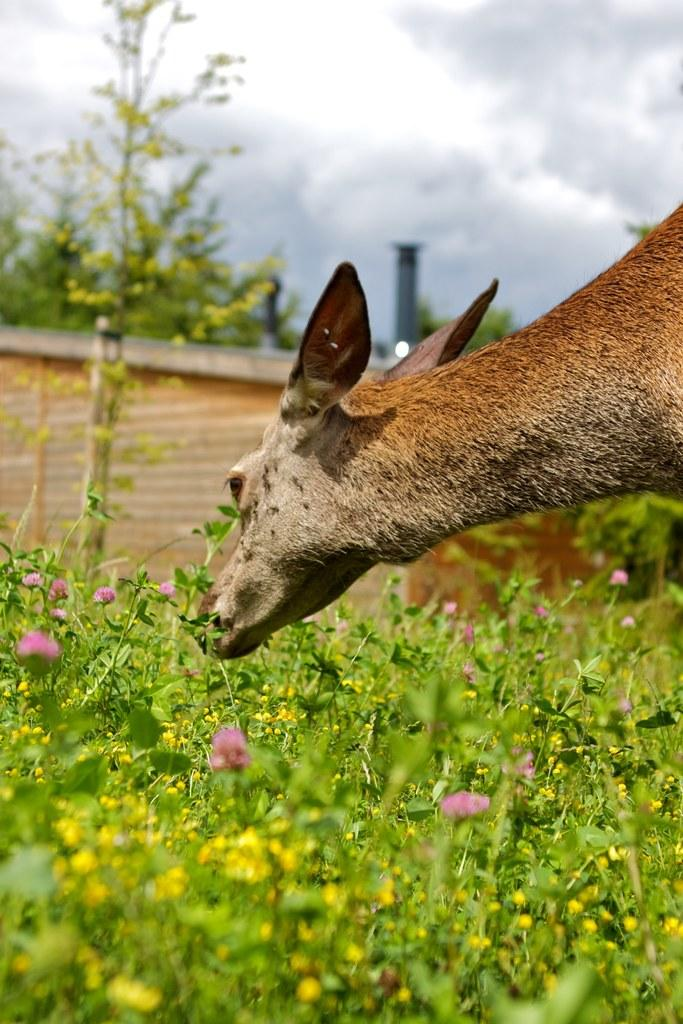What type of plants are at the bottom of the image? There are flower plants at the bottom of the image. What is the main subject in the middle of the image? There is the head of an animal in the middle of the image. What can be seen at the top of the image? The sky is visible at the top of the image. How would you describe the sky in the image? The sky appears to be cloudy. What type of metal is used to create the muscle of the animal in the image? There is no metal or muscle present in the image, as it only features the head of an animal. How many seats are visible in the image? There are no seats present in the image. 